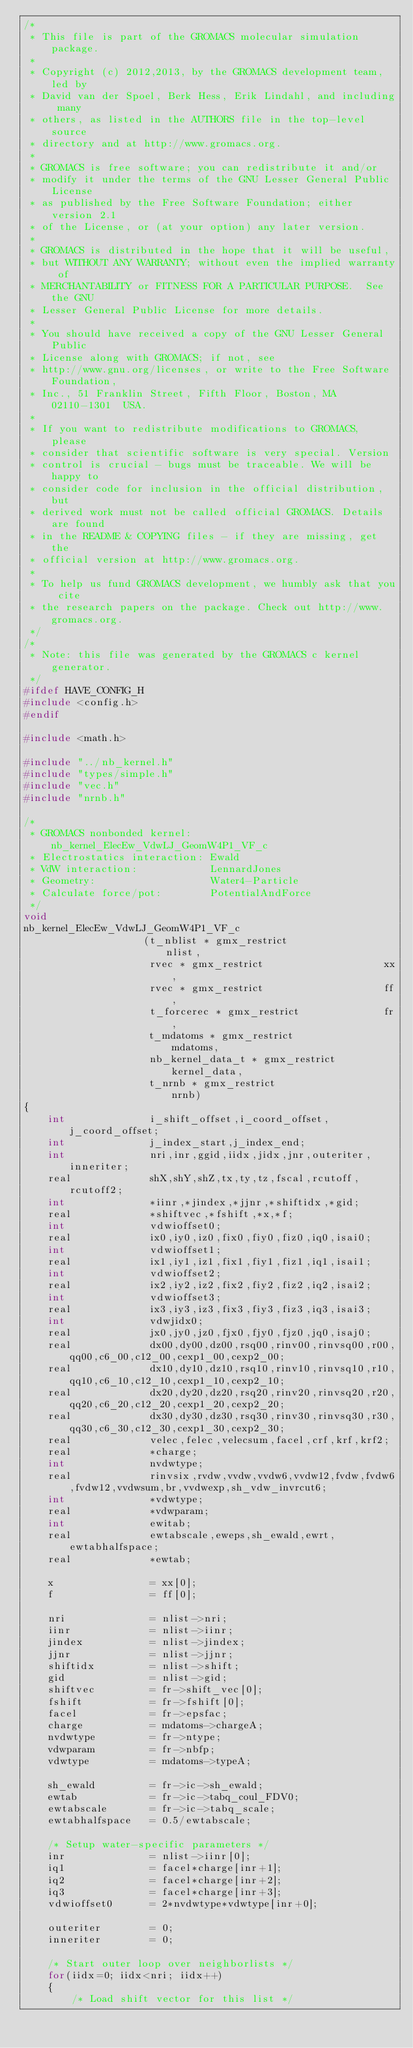<code> <loc_0><loc_0><loc_500><loc_500><_C_>/*
 * This file is part of the GROMACS molecular simulation package.
 *
 * Copyright (c) 2012,2013, by the GROMACS development team, led by
 * David van der Spoel, Berk Hess, Erik Lindahl, and including many
 * others, as listed in the AUTHORS file in the top-level source
 * directory and at http://www.gromacs.org.
 *
 * GROMACS is free software; you can redistribute it and/or
 * modify it under the terms of the GNU Lesser General Public License
 * as published by the Free Software Foundation; either version 2.1
 * of the License, or (at your option) any later version.
 *
 * GROMACS is distributed in the hope that it will be useful,
 * but WITHOUT ANY WARRANTY; without even the implied warranty of
 * MERCHANTABILITY or FITNESS FOR A PARTICULAR PURPOSE.  See the GNU
 * Lesser General Public License for more details.
 *
 * You should have received a copy of the GNU Lesser General Public
 * License along with GROMACS; if not, see
 * http://www.gnu.org/licenses, or write to the Free Software Foundation,
 * Inc., 51 Franklin Street, Fifth Floor, Boston, MA  02110-1301  USA.
 *
 * If you want to redistribute modifications to GROMACS, please
 * consider that scientific software is very special. Version
 * control is crucial - bugs must be traceable. We will be happy to
 * consider code for inclusion in the official distribution, but
 * derived work must not be called official GROMACS. Details are found
 * in the README & COPYING files - if they are missing, get the
 * official version at http://www.gromacs.org.
 *
 * To help us fund GROMACS development, we humbly ask that you cite
 * the research papers on the package. Check out http://www.gromacs.org.
 */
/*
 * Note: this file was generated by the GROMACS c kernel generator.
 */
#ifdef HAVE_CONFIG_H
#include <config.h>
#endif

#include <math.h>

#include "../nb_kernel.h"
#include "types/simple.h"
#include "vec.h"
#include "nrnb.h"

/*
 * GROMACS nonbonded kernel:   nb_kernel_ElecEw_VdwLJ_GeomW4P1_VF_c
 * Electrostatics interaction: Ewald
 * VdW interaction:            LennardJones
 * Geometry:                   Water4-Particle
 * Calculate force/pot:        PotentialAndForce
 */
void
nb_kernel_ElecEw_VdwLJ_GeomW4P1_VF_c
                    (t_nblist * gmx_restrict                nlist,
                     rvec * gmx_restrict                    xx,
                     rvec * gmx_restrict                    ff,
                     t_forcerec * gmx_restrict              fr,
                     t_mdatoms * gmx_restrict               mdatoms,
                     nb_kernel_data_t * gmx_restrict        kernel_data,
                     t_nrnb * gmx_restrict                  nrnb)
{
    int              i_shift_offset,i_coord_offset,j_coord_offset;
    int              j_index_start,j_index_end;
    int              nri,inr,ggid,iidx,jidx,jnr,outeriter,inneriter;
    real             shX,shY,shZ,tx,ty,tz,fscal,rcutoff,rcutoff2;
    int              *iinr,*jindex,*jjnr,*shiftidx,*gid;
    real             *shiftvec,*fshift,*x,*f;
    int              vdwioffset0;
    real             ix0,iy0,iz0,fix0,fiy0,fiz0,iq0,isai0;
    int              vdwioffset1;
    real             ix1,iy1,iz1,fix1,fiy1,fiz1,iq1,isai1;
    int              vdwioffset2;
    real             ix2,iy2,iz2,fix2,fiy2,fiz2,iq2,isai2;
    int              vdwioffset3;
    real             ix3,iy3,iz3,fix3,fiy3,fiz3,iq3,isai3;
    int              vdwjidx0;
    real             jx0,jy0,jz0,fjx0,fjy0,fjz0,jq0,isaj0;
    real             dx00,dy00,dz00,rsq00,rinv00,rinvsq00,r00,qq00,c6_00,c12_00,cexp1_00,cexp2_00;
    real             dx10,dy10,dz10,rsq10,rinv10,rinvsq10,r10,qq10,c6_10,c12_10,cexp1_10,cexp2_10;
    real             dx20,dy20,dz20,rsq20,rinv20,rinvsq20,r20,qq20,c6_20,c12_20,cexp1_20,cexp2_20;
    real             dx30,dy30,dz30,rsq30,rinv30,rinvsq30,r30,qq30,c6_30,c12_30,cexp1_30,cexp2_30;
    real             velec,felec,velecsum,facel,crf,krf,krf2;
    real             *charge;
    int              nvdwtype;
    real             rinvsix,rvdw,vvdw,vvdw6,vvdw12,fvdw,fvdw6,fvdw12,vvdwsum,br,vvdwexp,sh_vdw_invrcut6;
    int              *vdwtype;
    real             *vdwparam;
    int              ewitab;
    real             ewtabscale,eweps,sh_ewald,ewrt,ewtabhalfspace;
    real             *ewtab;

    x                = xx[0];
    f                = ff[0];

    nri              = nlist->nri;
    iinr             = nlist->iinr;
    jindex           = nlist->jindex;
    jjnr             = nlist->jjnr;
    shiftidx         = nlist->shift;
    gid              = nlist->gid;
    shiftvec         = fr->shift_vec[0];
    fshift           = fr->fshift[0];
    facel            = fr->epsfac;
    charge           = mdatoms->chargeA;
    nvdwtype         = fr->ntype;
    vdwparam         = fr->nbfp;
    vdwtype          = mdatoms->typeA;

    sh_ewald         = fr->ic->sh_ewald;
    ewtab            = fr->ic->tabq_coul_FDV0;
    ewtabscale       = fr->ic->tabq_scale;
    ewtabhalfspace   = 0.5/ewtabscale;

    /* Setup water-specific parameters */
    inr              = nlist->iinr[0];
    iq1              = facel*charge[inr+1];
    iq2              = facel*charge[inr+2];
    iq3              = facel*charge[inr+3];
    vdwioffset0      = 2*nvdwtype*vdwtype[inr+0];

    outeriter        = 0;
    inneriter        = 0;

    /* Start outer loop over neighborlists */
    for(iidx=0; iidx<nri; iidx++)
    {
        /* Load shift vector for this list */</code> 